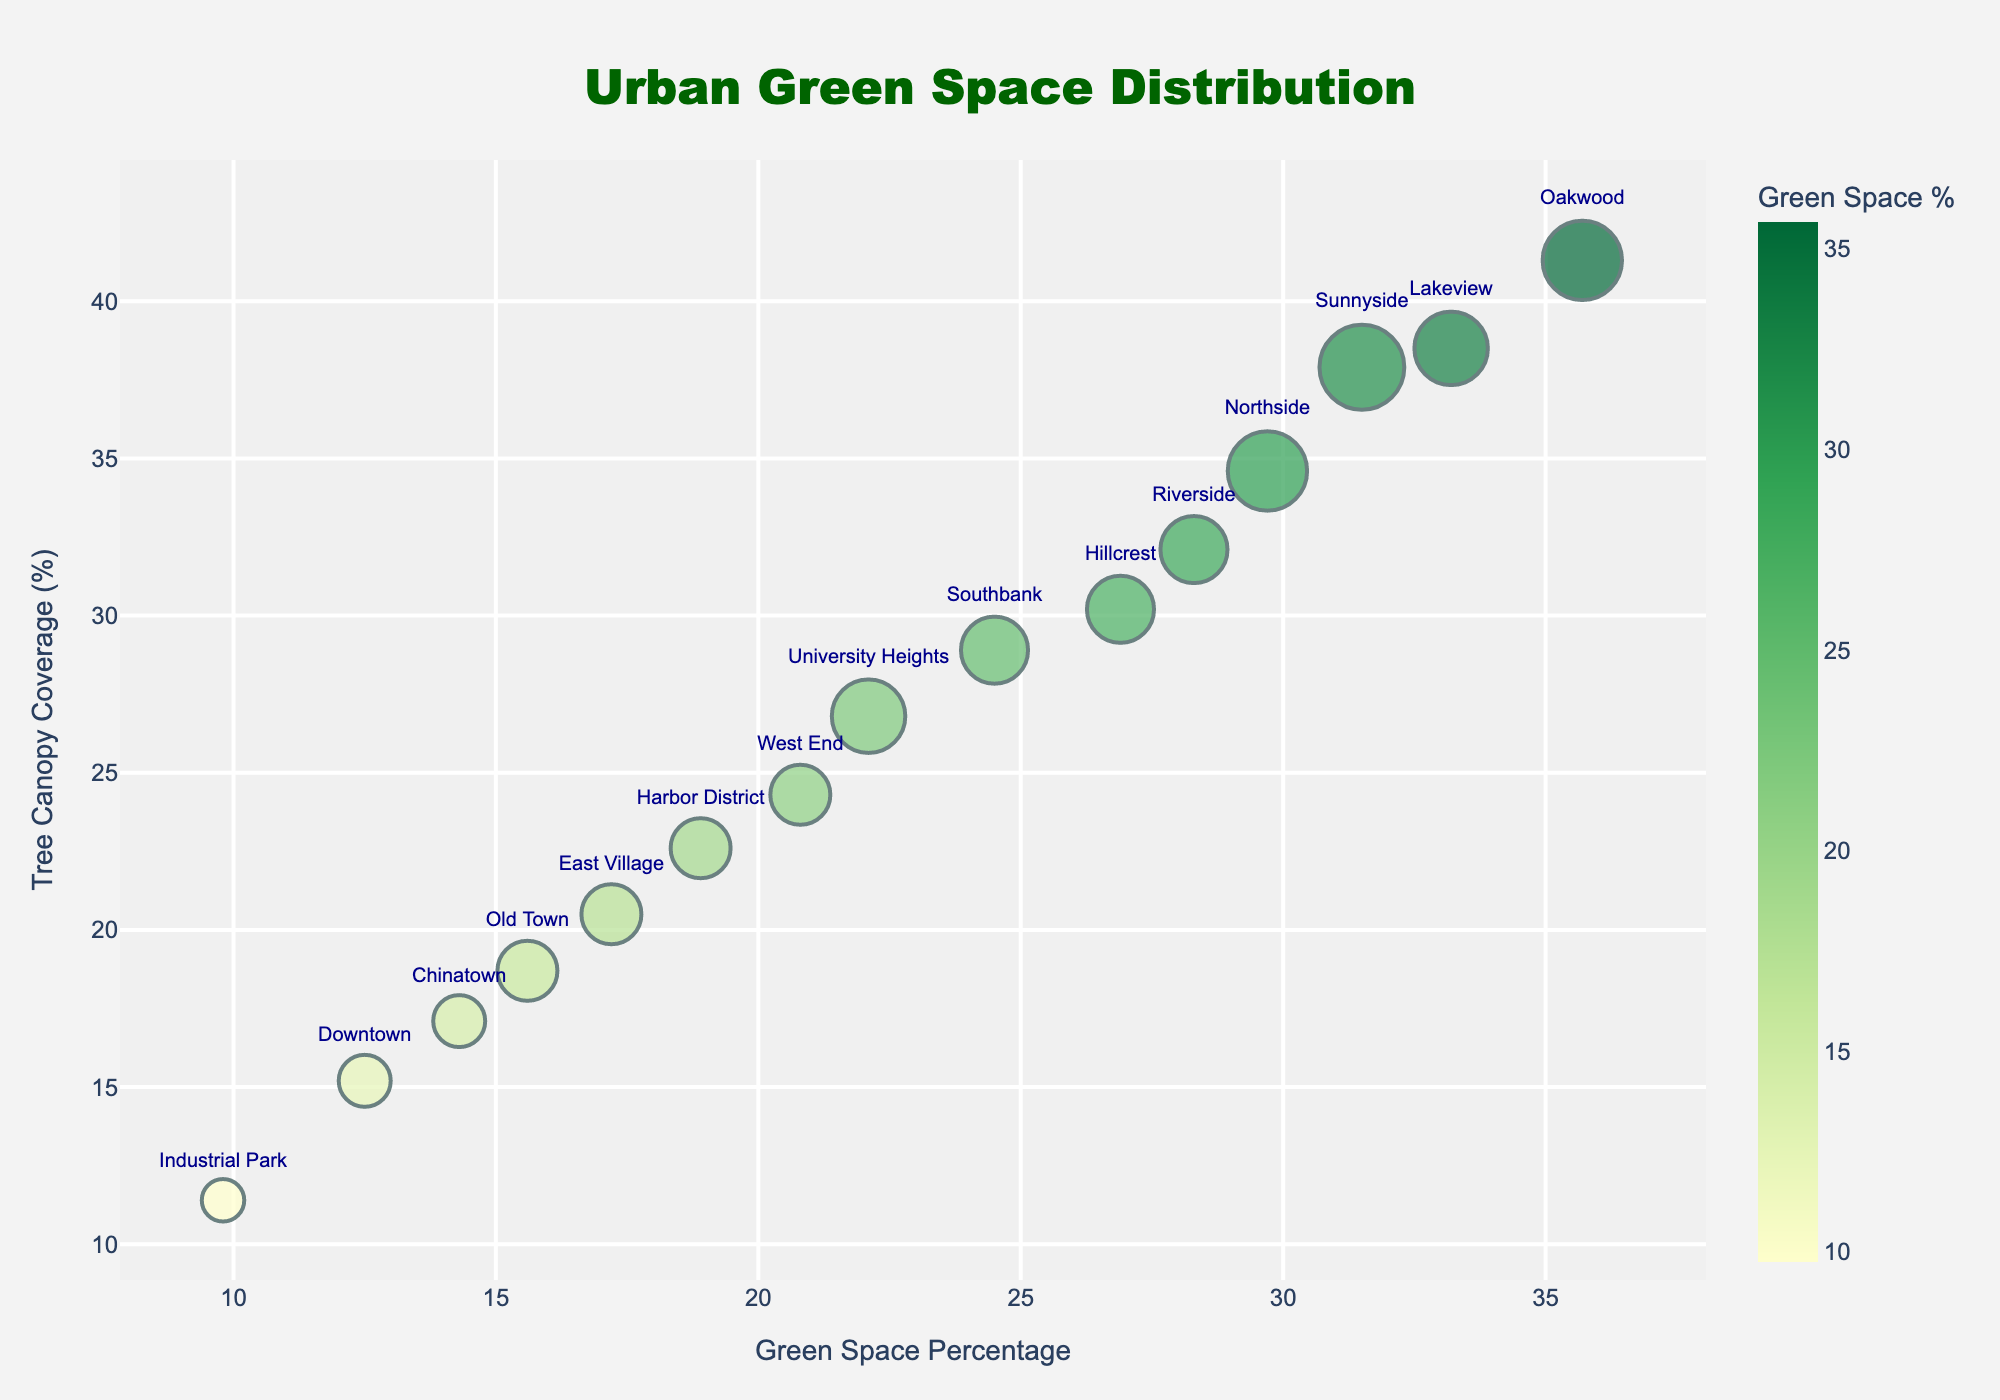What's the title of the figure? The title of the figure is usually located at the top. Here, the title reads "Urban Green Space Distribution", indicating that the plot is about the dispersion of green spaces across different neighborhoods in the city.
Answer: Urban Green Space Distribution Which neighborhood has the highest green space percentage? To answer this question, you need to identify the neighborhood with the furthest right position on the x-axis. "Oakwood" is positioned at the rightmost point on the x-axis at 35.7%.
Answer: Oakwood How many neighborhoods have more than 30% green space? Look at the x-axis representing "Green Space Percentage" and count the number of points beyond 30%. The neighborhoods are Oakwood, Sunnyside, Lakeview, and Northside.
Answer: 4 Which neighborhood has the smallest tree canopy coverage? Look at the y-axis representing "Tree Canopy Coverage" and find the lowest point. "Industrial Park" is the lowest, at 11.4%.
Answer: Industrial Park Which two neighborhoods have an equal number of parks but different green space percentages? You need to locate neighborhoods with the same bubble size but different x-axis values. "Hillcrest" and "Riverside" each have 5 parks (equal size dots) but different green space percentages (Hillcrest: 26.9%, Riverside: 28.3%).
Answer: Hillcrest, Riverside What's the average tree canopy coverage for neighborhoods with more than 25% green space? First, identify neighborhoods with more than 25% green space: Riverside, Oakwood, Sunnyside, Hillcrest, Lakeview, Northside. Then, average their tree canopy coverages: (32.1 + 41.3 + 37.9 + 30.2 + 38.5 + 34.6) / 6 = 35.769%.
Answer: 35.8% Which neighborhood has the highest tree canopy coverage? Identify the highest point on the y-axis representing "Tree Canopy Coverage". "Oakwood" at 41.3% is the highest.
Answer: Oakwood Compare Downtown and Old Town based on green space and tree canopy coverage. Which is better? Downtown has 12.5% green space and 15.2% tree canopy coverage, whereas Old Town has 15.6% green space and 18.7% tree canopy coverage. Old Town has higher values in both metrics.
Answer: Old Town What is the combined number of parks in Riverside and University Heights? Look at the bubble sizes for Riverside and University Heights, which correspond to 5 and 6 parks, respectively. Adding these, the combined number is 5 + 6 = 11.
Answer: 11 If we rank neighborhoods by tree canopy coverage, which one comes after Lakeview? Start by identifying the tree canopy coverage values: Oakwood (41.3), Sunnyside (37.9), Lakeview (38.5), Northside (34.6). The one that comes immediately after Lakeview in descending order is Northside with 34.6%.
Answer: Northside 